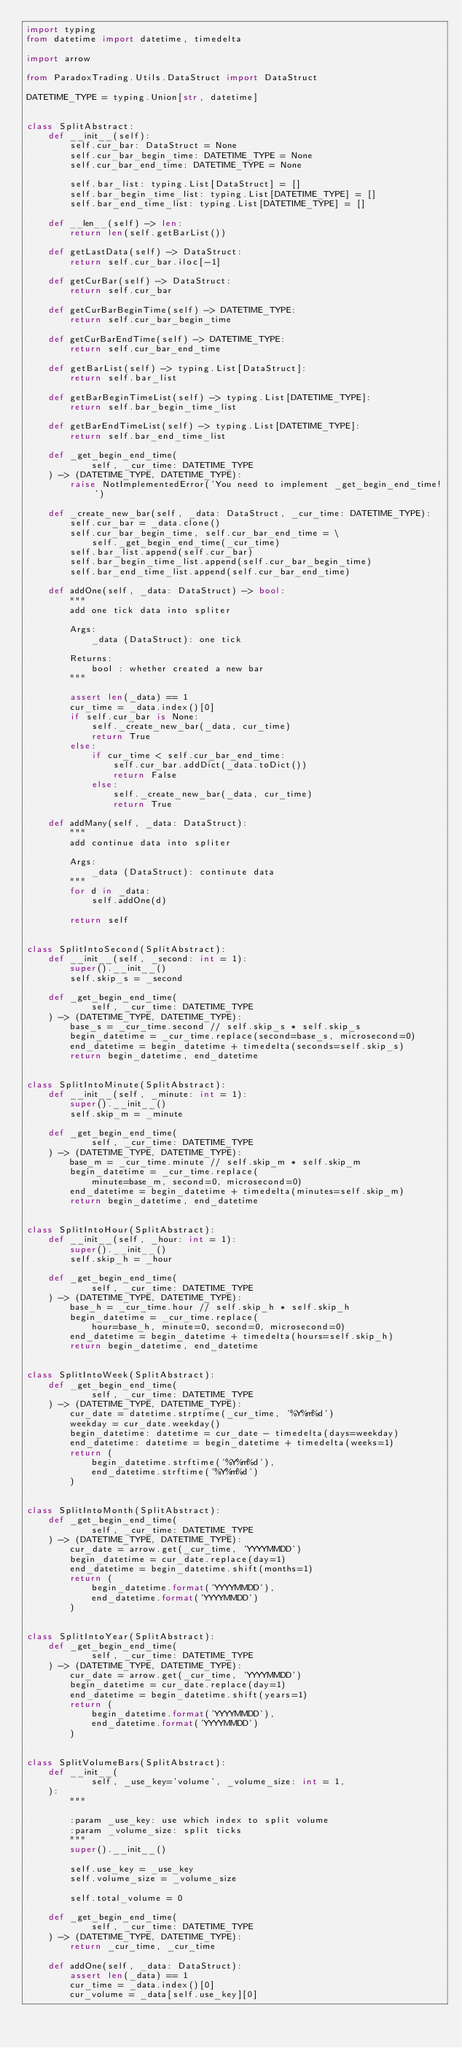Convert code to text. <code><loc_0><loc_0><loc_500><loc_500><_Python_>import typing
from datetime import datetime, timedelta

import arrow

from ParadoxTrading.Utils.DataStruct import DataStruct

DATETIME_TYPE = typing.Union[str, datetime]


class SplitAbstract:
    def __init__(self):
        self.cur_bar: DataStruct = None
        self.cur_bar_begin_time: DATETIME_TYPE = None
        self.cur_bar_end_time: DATETIME_TYPE = None

        self.bar_list: typing.List[DataStruct] = []
        self.bar_begin_time_list: typing.List[DATETIME_TYPE] = []
        self.bar_end_time_list: typing.List[DATETIME_TYPE] = []

    def __len__(self) -> len:
        return len(self.getBarList())

    def getLastData(self) -> DataStruct:
        return self.cur_bar.iloc[-1]

    def getCurBar(self) -> DataStruct:
        return self.cur_bar

    def getCurBarBeginTime(self) -> DATETIME_TYPE:
        return self.cur_bar_begin_time

    def getCurBarEndTime(self) -> DATETIME_TYPE:
        return self.cur_bar_end_time

    def getBarList(self) -> typing.List[DataStruct]:
        return self.bar_list

    def getBarBeginTimeList(self) -> typing.List[DATETIME_TYPE]:
        return self.bar_begin_time_list

    def getBarEndTimeList(self) -> typing.List[DATETIME_TYPE]:
        return self.bar_end_time_list

    def _get_begin_end_time(
            self, _cur_time: DATETIME_TYPE
    ) -> (DATETIME_TYPE, DATETIME_TYPE):
        raise NotImplementedError('You need to implement _get_begin_end_time!')

    def _create_new_bar(self, _data: DataStruct, _cur_time: DATETIME_TYPE):
        self.cur_bar = _data.clone()
        self.cur_bar_begin_time, self.cur_bar_end_time = \
            self._get_begin_end_time(_cur_time)
        self.bar_list.append(self.cur_bar)
        self.bar_begin_time_list.append(self.cur_bar_begin_time)
        self.bar_end_time_list.append(self.cur_bar_end_time)

    def addOne(self, _data: DataStruct) -> bool:
        """
        add one tick data into spliter

        Args:
            _data (DataStruct): one tick

        Returns:
            bool : whether created a new bar
        """

        assert len(_data) == 1
        cur_time = _data.index()[0]
        if self.cur_bar is None:
            self._create_new_bar(_data, cur_time)
            return True
        else:
            if cur_time < self.cur_bar_end_time:
                self.cur_bar.addDict(_data.toDict())
                return False
            else:
                self._create_new_bar(_data, cur_time)
                return True

    def addMany(self, _data: DataStruct):
        """
        add continue data into spliter

        Args:
            _data (DataStruct): continute data
        """
        for d in _data:
            self.addOne(d)

        return self


class SplitIntoSecond(SplitAbstract):
    def __init__(self, _second: int = 1):
        super().__init__()
        self.skip_s = _second

    def _get_begin_end_time(
            self, _cur_time: DATETIME_TYPE
    ) -> (DATETIME_TYPE, DATETIME_TYPE):
        base_s = _cur_time.second // self.skip_s * self.skip_s
        begin_datetime = _cur_time.replace(second=base_s, microsecond=0)
        end_datetime = begin_datetime + timedelta(seconds=self.skip_s)
        return begin_datetime, end_datetime


class SplitIntoMinute(SplitAbstract):
    def __init__(self, _minute: int = 1):
        super().__init__()
        self.skip_m = _minute

    def _get_begin_end_time(
            self, _cur_time: DATETIME_TYPE
    ) -> (DATETIME_TYPE, DATETIME_TYPE):
        base_m = _cur_time.minute // self.skip_m * self.skip_m
        begin_datetime = _cur_time.replace(
            minute=base_m, second=0, microsecond=0)
        end_datetime = begin_datetime + timedelta(minutes=self.skip_m)
        return begin_datetime, end_datetime


class SplitIntoHour(SplitAbstract):
    def __init__(self, _hour: int = 1):
        super().__init__()
        self.skip_h = _hour

    def _get_begin_end_time(
            self, _cur_time: DATETIME_TYPE
    ) -> (DATETIME_TYPE, DATETIME_TYPE):
        base_h = _cur_time.hour // self.skip_h * self.skip_h
        begin_datetime = _cur_time.replace(
            hour=base_h, minute=0, second=0, microsecond=0)
        end_datetime = begin_datetime + timedelta(hours=self.skip_h)
        return begin_datetime, end_datetime


class SplitIntoWeek(SplitAbstract):
    def _get_begin_end_time(
            self, _cur_time: DATETIME_TYPE
    ) -> (DATETIME_TYPE, DATETIME_TYPE):
        cur_date = datetime.strptime(_cur_time, '%Y%m%d')
        weekday = cur_date.weekday()
        begin_datetime: datetime = cur_date - timedelta(days=weekday)
        end_datetime: datetime = begin_datetime + timedelta(weeks=1)
        return (
            begin_datetime.strftime('%Y%m%d'),
            end_datetime.strftime('%Y%m%d')
        )


class SplitIntoMonth(SplitAbstract):
    def _get_begin_end_time(
            self, _cur_time: DATETIME_TYPE
    ) -> (DATETIME_TYPE, DATETIME_TYPE):
        cur_date = arrow.get(_cur_time, 'YYYYMMDD')
        begin_datetime = cur_date.replace(day=1)
        end_datetime = begin_datetime.shift(months=1)
        return (
            begin_datetime.format('YYYYMMDD'),
            end_datetime.format('YYYYMMDD')
        )


class SplitIntoYear(SplitAbstract):
    def _get_begin_end_time(
            self, _cur_time: DATETIME_TYPE
    ) -> (DATETIME_TYPE, DATETIME_TYPE):
        cur_date = arrow.get(_cur_time, 'YYYYMMDD')
        begin_datetime = cur_date.replace(day=1)
        end_datetime = begin_datetime.shift(years=1)
        return (
            begin_datetime.format('YYYYMMDD'),
            end_datetime.format('YYYYMMDD')
        )


class SplitVolumeBars(SplitAbstract):
    def __init__(
            self, _use_key='volume', _volume_size: int = 1,
    ):
        """

        :param _use_key: use which index to split volume
        :param _volume_size: split ticks
        """
        super().__init__()

        self.use_key = _use_key
        self.volume_size = _volume_size

        self.total_volume = 0

    def _get_begin_end_time(
            self, _cur_time: DATETIME_TYPE
    ) -> (DATETIME_TYPE, DATETIME_TYPE):
        return _cur_time, _cur_time

    def addOne(self, _data: DataStruct):
        assert len(_data) == 1
        cur_time = _data.index()[0]
        cur_volume = _data[self.use_key][0]</code> 